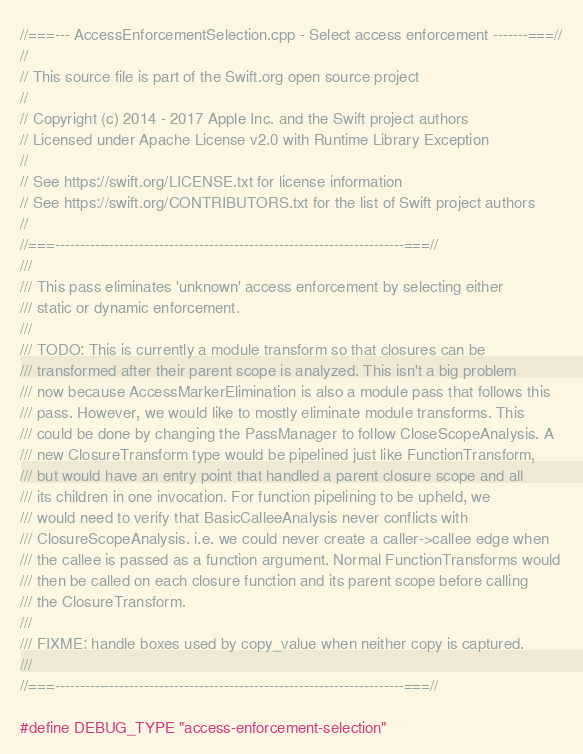<code> <loc_0><loc_0><loc_500><loc_500><_C++_>//===--- AccessEnforcementSelection.cpp - Select access enforcement -------===//
//
// This source file is part of the Swift.org open source project
//
// Copyright (c) 2014 - 2017 Apple Inc. and the Swift project authors
// Licensed under Apache License v2.0 with Runtime Library Exception
//
// See https://swift.org/LICENSE.txt for license information
// See https://swift.org/CONTRIBUTORS.txt for the list of Swift project authors
//
//===----------------------------------------------------------------------===//
///
/// This pass eliminates 'unknown' access enforcement by selecting either
/// static or dynamic enforcement.
///
/// TODO: This is currently a module transform so that closures can be
/// transformed after their parent scope is analyzed. This isn't a big problem
/// now because AccessMarkerElimination is also a module pass that follows this
/// pass. However, we would like to mostly eliminate module transforms. This
/// could be done by changing the PassManager to follow CloseScopeAnalysis. A
/// new ClosureTransform type would be pipelined just like FunctionTransform,
/// but would have an entry point that handled a parent closure scope and all
/// its children in one invocation. For function pipelining to be upheld, we
/// would need to verify that BasicCalleeAnalysis never conflicts with
/// ClosureScopeAnalysis. i.e. we could never create a caller->callee edge when
/// the callee is passed as a function argument. Normal FunctionTransforms would
/// then be called on each closure function and its parent scope before calling
/// the ClosureTransform.
///
/// FIXME: handle boxes used by copy_value when neither copy is captured.
///
//===----------------------------------------------------------------------===//

#define DEBUG_TYPE "access-enforcement-selection"</code> 